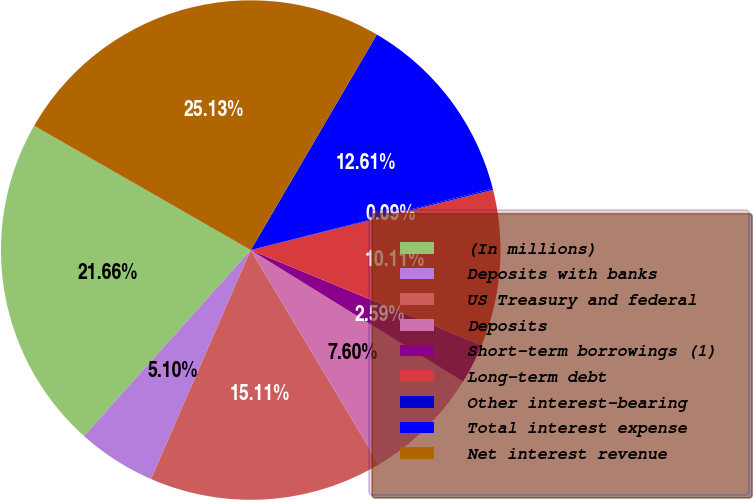<chart> <loc_0><loc_0><loc_500><loc_500><pie_chart><fcel>(In millions)<fcel>Deposits with banks<fcel>US Treasury and federal<fcel>Deposits<fcel>Short-term borrowings (1)<fcel>Long-term debt<fcel>Other interest-bearing<fcel>Total interest expense<fcel>Net interest revenue<nl><fcel>21.66%<fcel>5.1%<fcel>15.11%<fcel>7.6%<fcel>2.59%<fcel>10.11%<fcel>0.09%<fcel>12.61%<fcel>25.13%<nl></chart> 